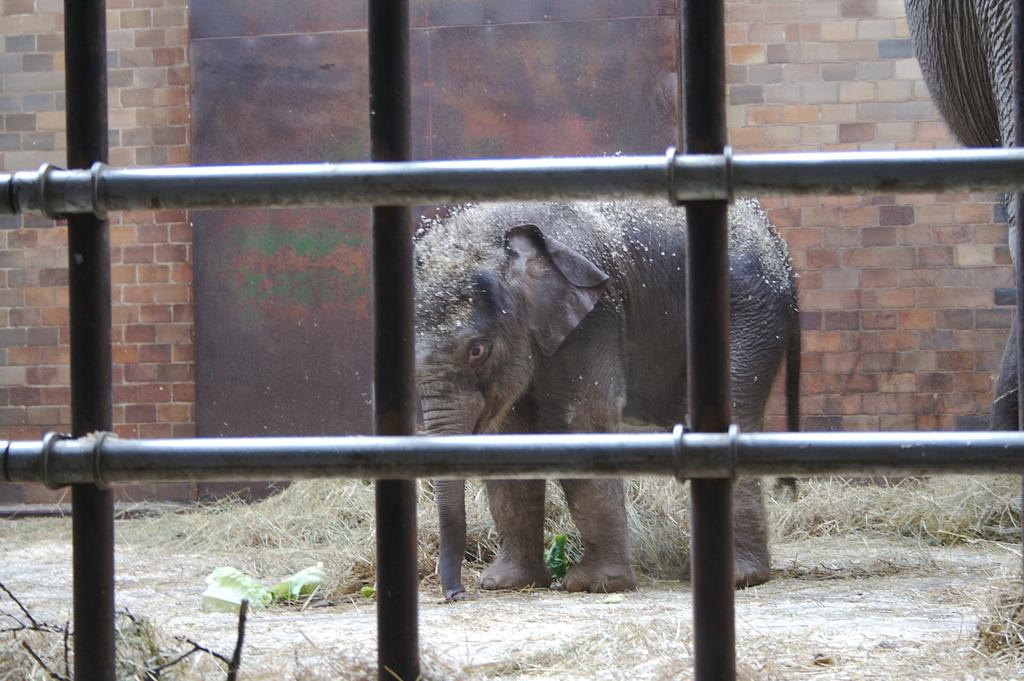What type of barrier is visible in the image? There is an iron fence in the image. What animal can be seen on the ground in the image? There is an elephant on the ground in the image. What type of vegetation is present on the ground in the image? Grass is present on the ground in the image. What type of structure can be seen in the background of the image? There is a brick wall in the background of the image. Where is the stove located in the image? There is no stove present in the image. What type of root can be seen growing near the elephant in the image? There are no roots visible in the image; it features an elephant on the ground and an iron fence. 